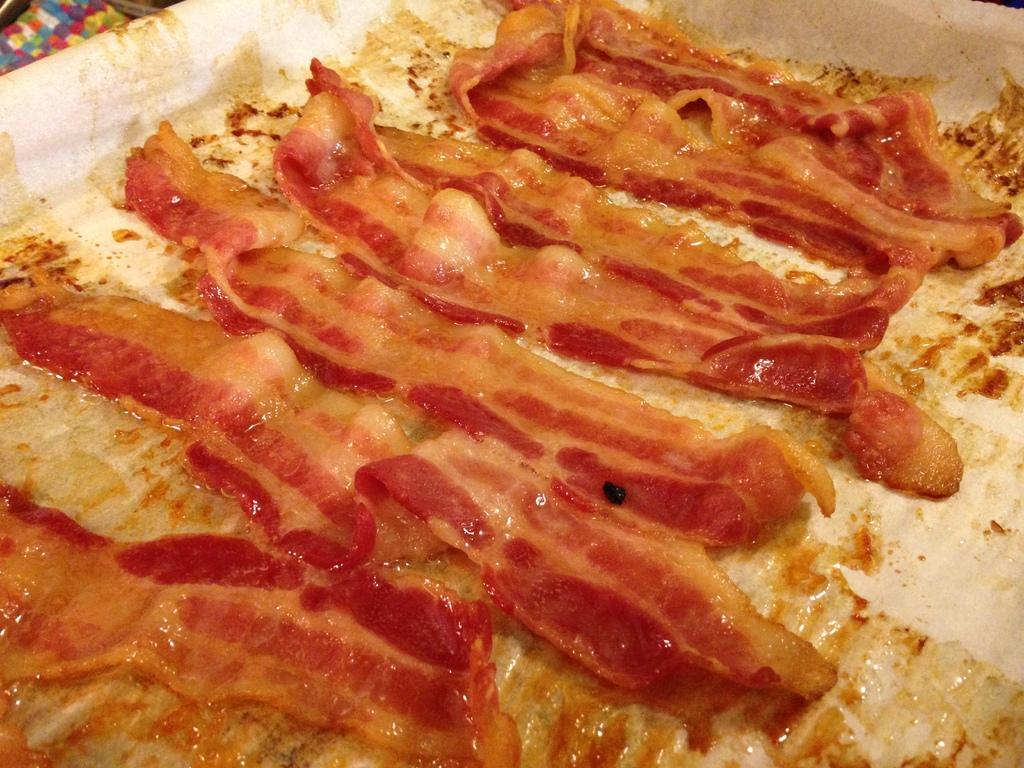What is the main subject of the image? There is a food item in the image. What color is the food item? The food item is in red color. How is the food item placed in the image? The food item is kept in a white color tray. Can you see a stamp on the food item in the image? There is no stamp visible on the food item in the image. 